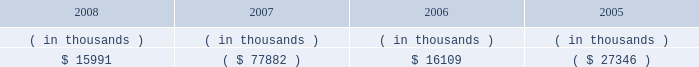Entergy arkansas , inc .
Management's financial discussion and analysis financing alternatives for any such spending , and future spending estimates could change based on the results of this continuing analysis .
Entergy's utility supply plan initiative will continue to seek to transform its generation portfolio with new or repowered generation resources .
Opportunities resulting from the supply plan initiative , including new projects or the exploration of alternative financing sources , could result in increases or decreases in the capital expenditure estimates given above .
The estimated capital expenditures are subject to periodic review and modification and may vary based on the ongoing effects of regulatory constraints , market volatility , economic trends , environmental compliance , and the ability to access capital .
Management provides more information on long-term debt and preferred stock maturities in notes 5 and 6 to the financial statements .
As a wholly-owned subsidiary , entergy arkansas pays dividends to entergy corporation from its earnings at a percentage determined monthly .
Entergy arkansas' long-term debt indentures restrict the amount of retained earnings available for the payment of cash dividends or other distributions on its common and preferred stock .
As of december 31 , 2008 , entergy arkansas had restricted retained earnings unavailable for distribution to entergy corporation of $ 461.6 million .
Sources of capital entergy arkansas' sources to meet its capital requirements include : internally generated funds ; cash on hand ; debt or preferred stock issuances ; and bank financing under new or existing facilities .
Entergy arkansas may refinance or redeem debt and preferred stock prior to maturity , to the extent market conditions and interest and dividend rates are favorable .
All debt and common and preferred stock issuances by entergy arkansas require prior regulatory approval .
Preferred stock and debt issuances are also subject to issuance tests set forth in entergy arkansas' corporate charters , bond indentures , and other agreements .
Entergy arkansas has sufficient capacity under these tests to meet its foreseeable capital needs .
In april 2008 , entergy arkansas renewed its $ 100 million credit facility through april 2009 .
The credit facility requires that entergy arkansas maintain a debt ratio of 65% ( 65 % ) or less of it total capitalization .
There were no outstanding borrowings under the entergy arkansas credit facility as of december 31 , 2008 .
In july 2008 , entergy arkansas issued $ 300 million of 5.40% ( 5.40 % ) series first mortgage bonds due august 2013 .
Entergy arkansas used a portion of the net proceeds to fund the purchase of the ouachita power plant on september 30 , 2008 , and the remaining net proceeds will be used to fund improvements relating to the ouachita power plant and for general corporate purposes .
Entergy arkansas' receivables from or ( payables to ) the money pool were as follows as of december 31 for each of the following years: .
In may 2007 , $ 1.8 million of entergy arkansas' receivable from the money pool was replaced by a note receivable from entergy new orleans .
See note 4 to the financial statements for a description of the money pool. .
What is the annual interest expense related to the series first mortgage bonds due august 2013 , in millions? 
Computations: (300 * 5.40%)
Answer: 16.2. 